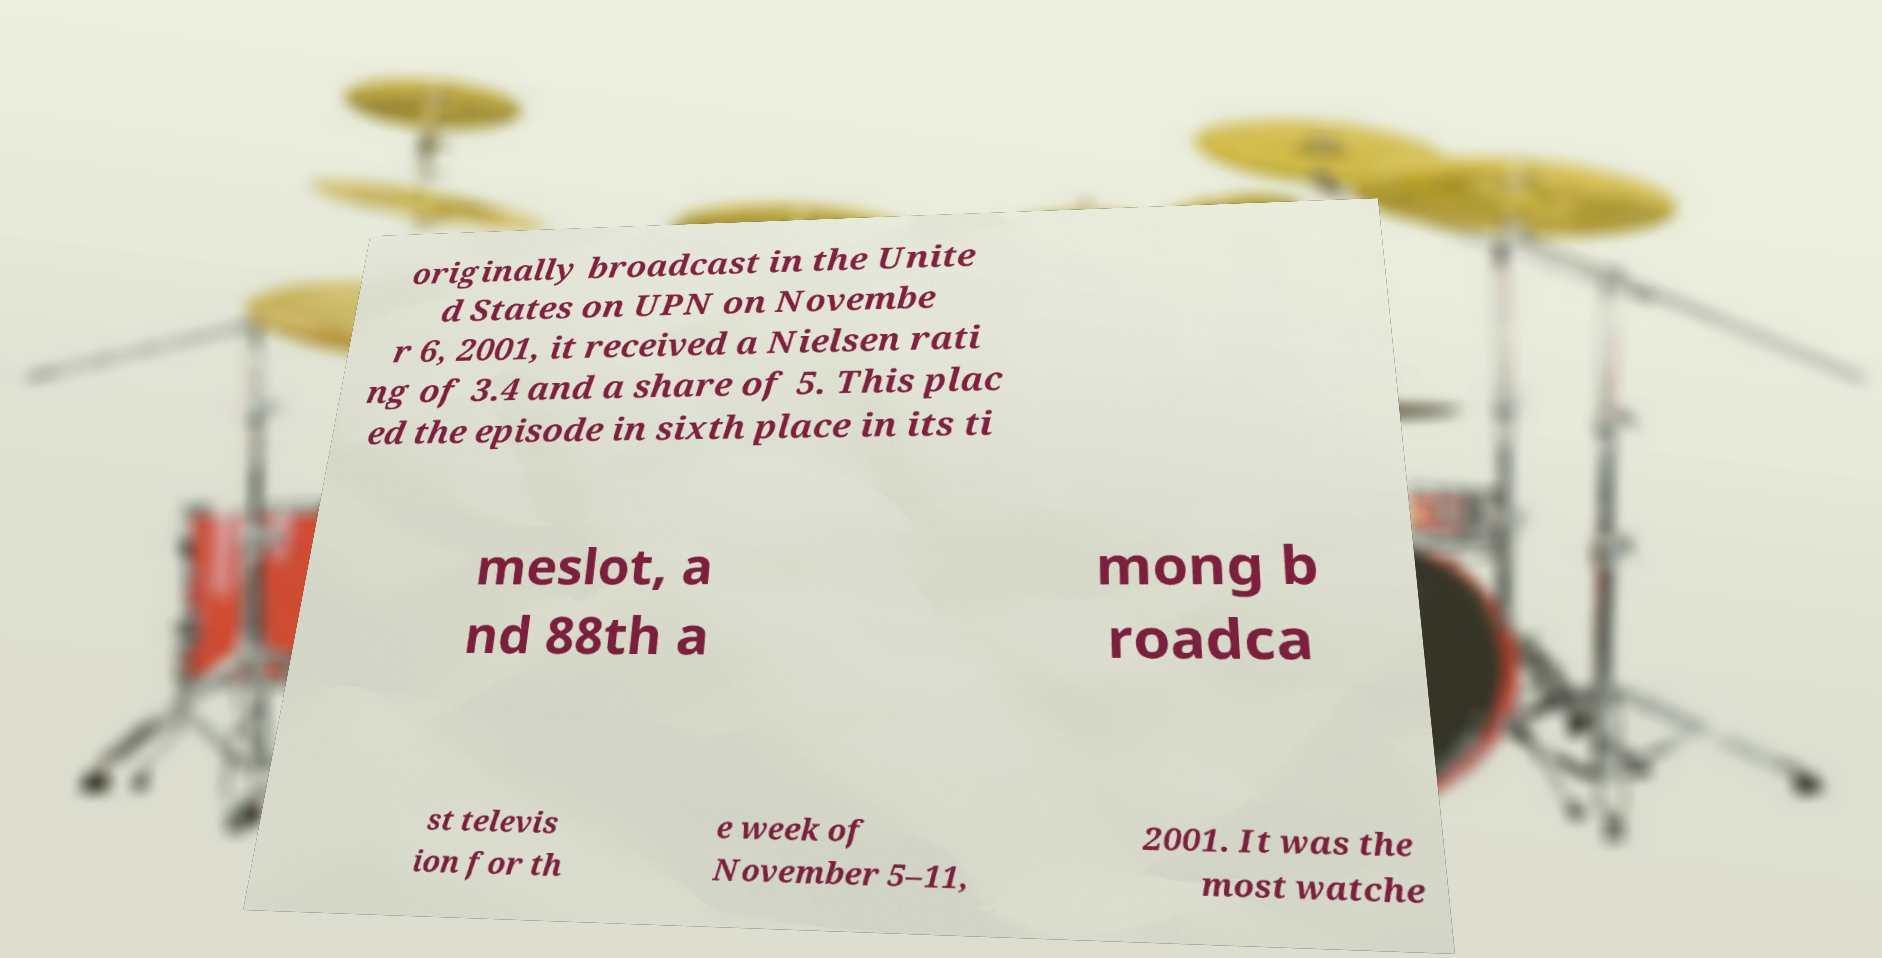What messages or text are displayed in this image? I need them in a readable, typed format. originally broadcast in the Unite d States on UPN on Novembe r 6, 2001, it received a Nielsen rati ng of 3.4 and a share of 5. This plac ed the episode in sixth place in its ti meslot, a nd 88th a mong b roadca st televis ion for th e week of November 5–11, 2001. It was the most watche 